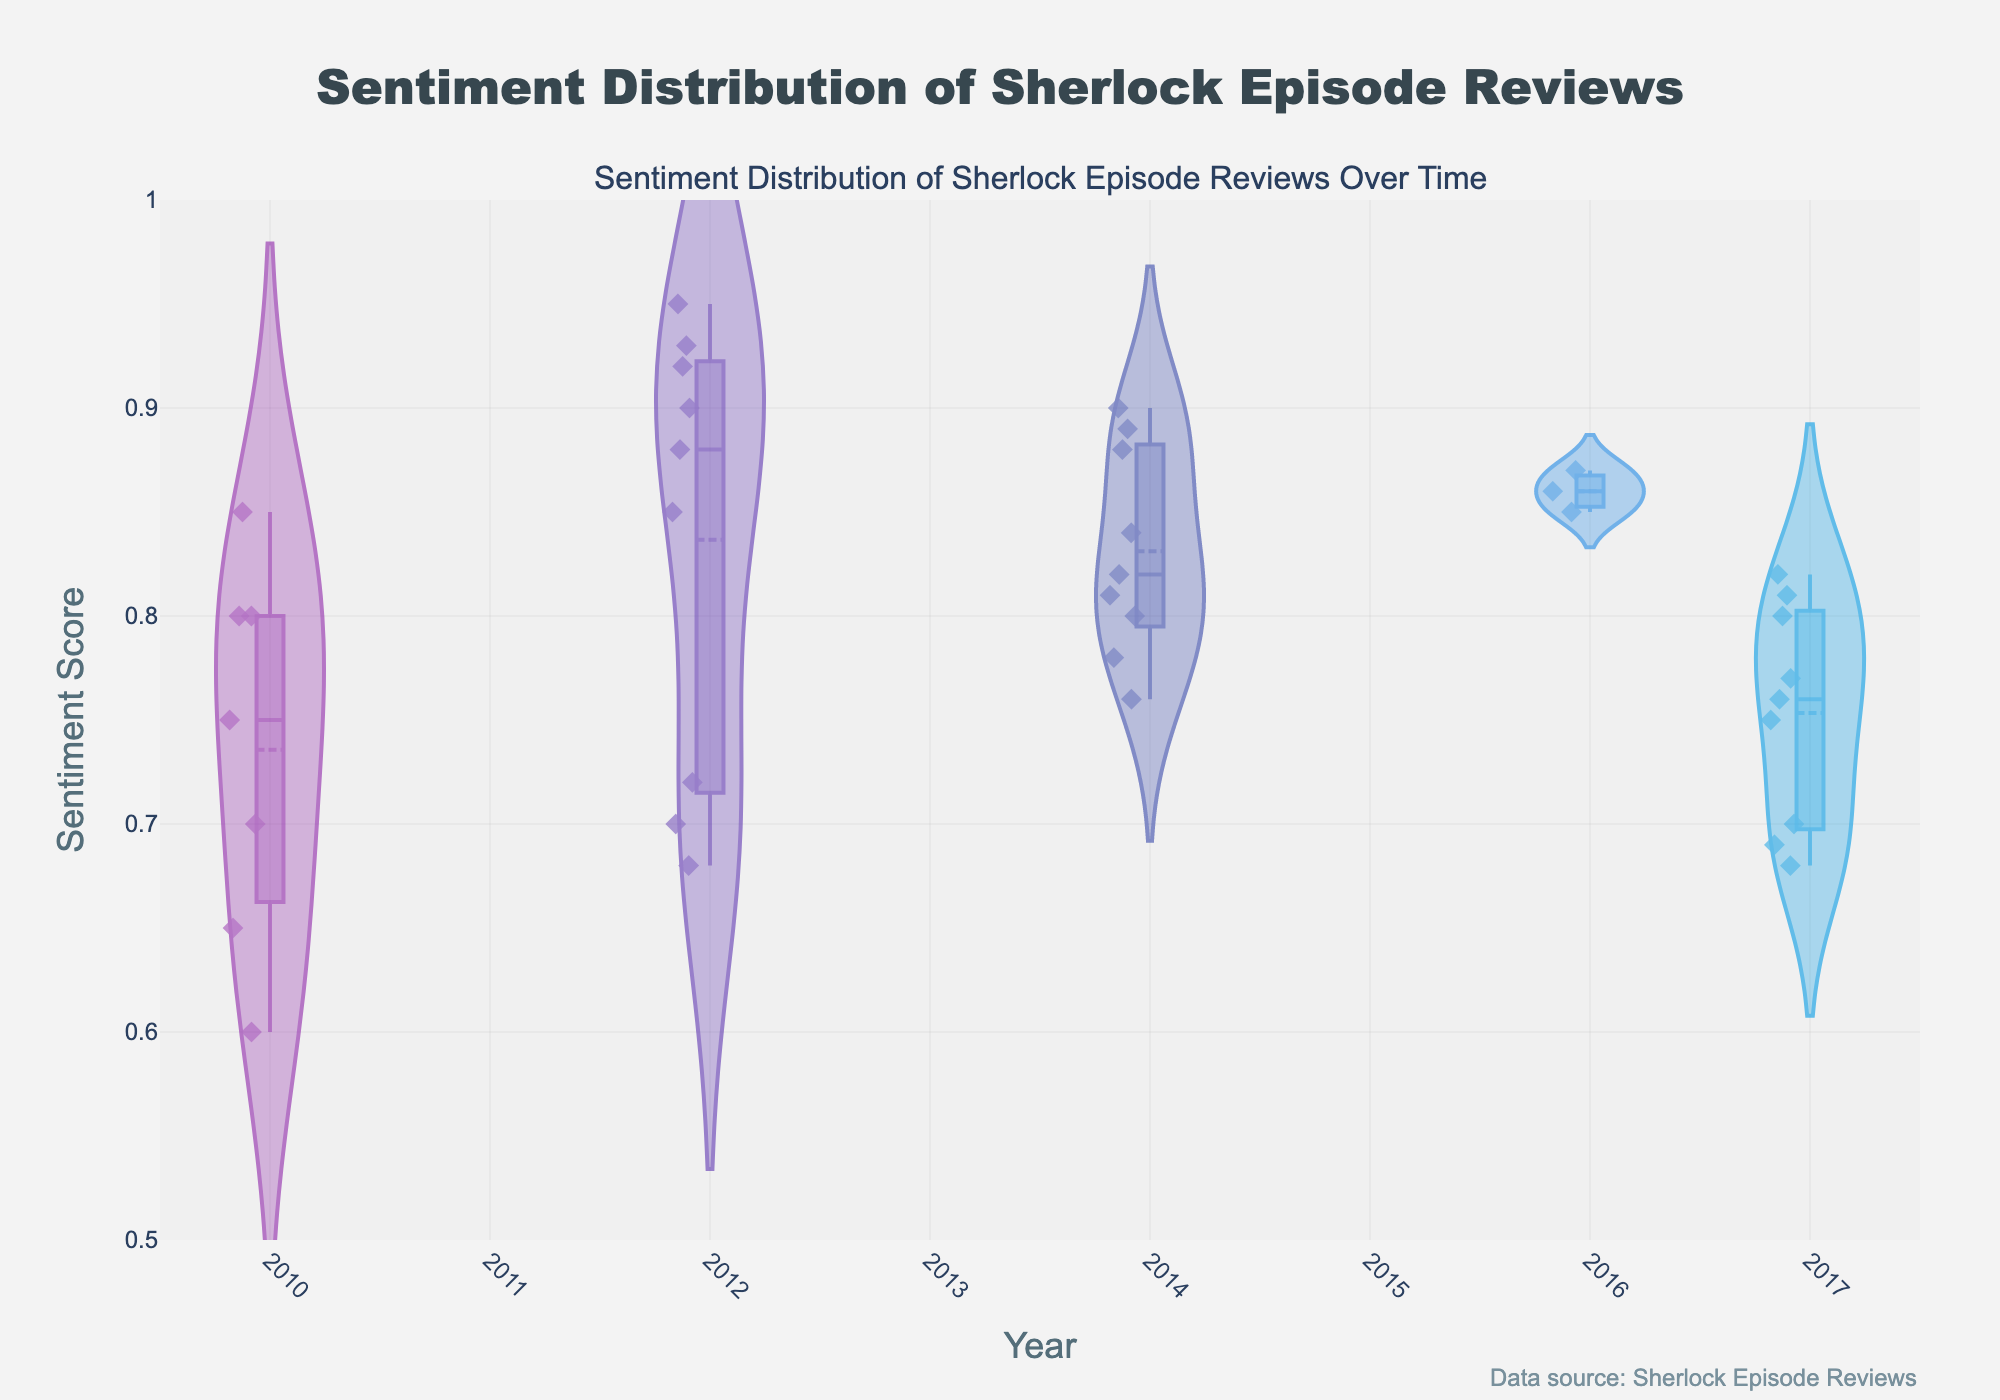What is the title of the plot? The title of the plot is displayed at the top. Reading it, we see "Sentiment Distribution of Sherlock Episode Reviews".
Answer: Sentiment Distribution of Sherlock Episode Reviews Which year has the highest mean sentiment score? The plot displays mean sentiment scores through horizontal lines within each year's violin plot. The highest line appears in 2012.
Answer: 2012 How many unique years are represented in the plot? By counting the distinct x-axis labels (years) shown at the bottom of the plot, it's clear there are multiple years. Upon visually verifying, we see there are 5 unique years represented.
Answer: 5 Is the mean sentiment score of "The Reichenbach Fall" higher than "The Blind Banker"? By observing the lines marking the mean sentiment scores within the violin plots for 2010 and 2012, we notice the line for "The Reichenbach Fall" (2012) is higher than that for "The Blind Banker" (2010).
Answer: Yes Which episode has the widest sentiment score distribution in 2014? Observing the spread of the violin plots for episodes in 2014, the widest spread (largest vertical area) indicates "His Last Vow" has the widest sentiment score distribution.
Answer: His Last Vow What's the lowest sentiment score in 2017? By looking at the bottom points of the 2017 violin plots, the lowest mark belongs to "The Six Thatchers" at 0.68.
Answer: 0.68 Compare the median sentiment scores of 2012 and 2014. Which year is higher? The median is indicated by the central line in the violin plots. Comparing the plots, the median line in 2012 is at a higher sentiment score than that in 2014.
Answer: 2012 What is the range of sentiment scores for "A Study in Pink"? Identifying the highest and lowest points in the violin plot for "A Study in Pink" (2010), the scores range from 0.70 to 0.80.
Answer: 0.60 - 0.80 How does the sentiment distribution for "The Abominable Bride" compare to that of "The Lying Detective"? By comparing the shapes of the violin plots for 2016 and 2017, "The Abominable Bride" shows a slightly tighter distribution of scores around the mean compared to "The Lying Detective" which has a wider distribution.
Answer: Tighter distribution in 2016 